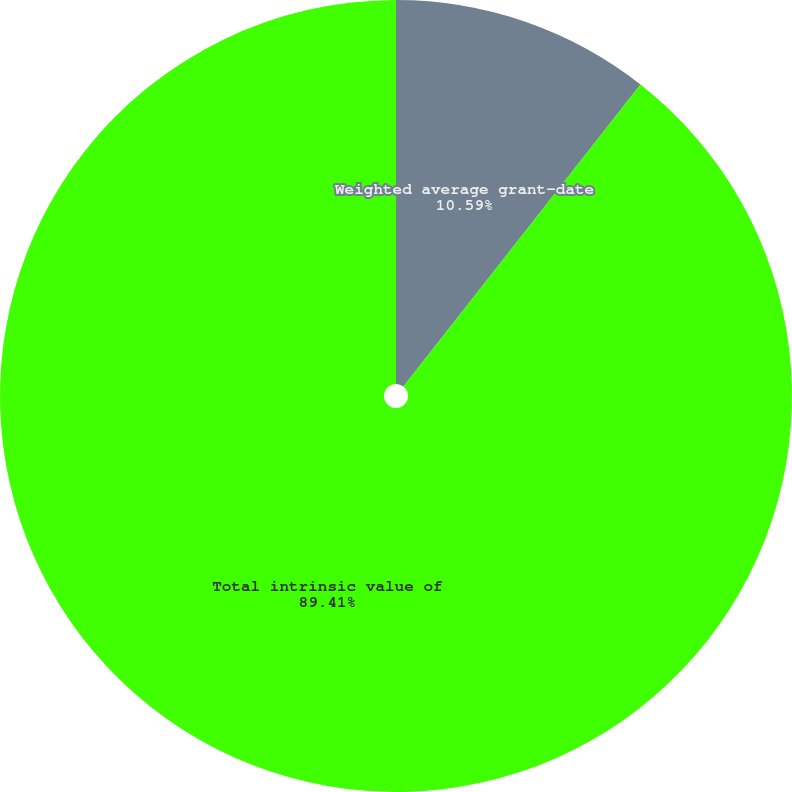Convert chart to OTSL. <chart><loc_0><loc_0><loc_500><loc_500><pie_chart><fcel>Weighted average grant-date<fcel>Total intrinsic value of<nl><fcel>10.59%<fcel>89.41%<nl></chart> 